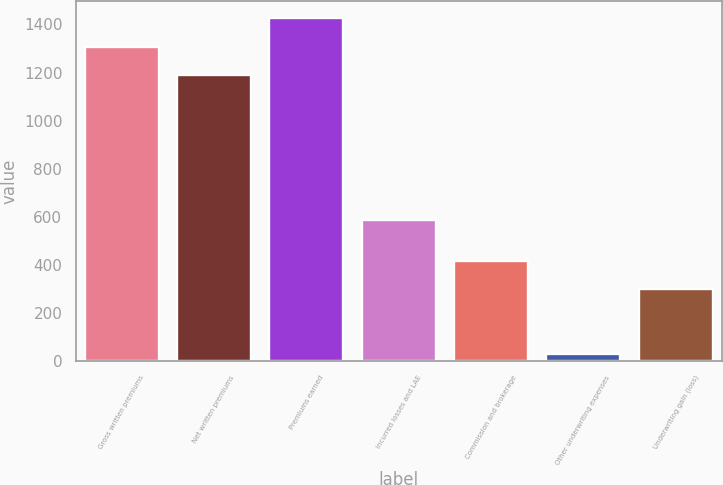Convert chart. <chart><loc_0><loc_0><loc_500><loc_500><bar_chart><fcel>Gross written premiums<fcel>Net written premiums<fcel>Premiums earned<fcel>Incurred losses and LAE<fcel>Commission and brokerage<fcel>Other underwriting expenses<fcel>Underwriting gain (loss)<nl><fcel>1307.25<fcel>1188.7<fcel>1425.8<fcel>586.3<fcel>417.65<fcel>29.3<fcel>299.1<nl></chart> 